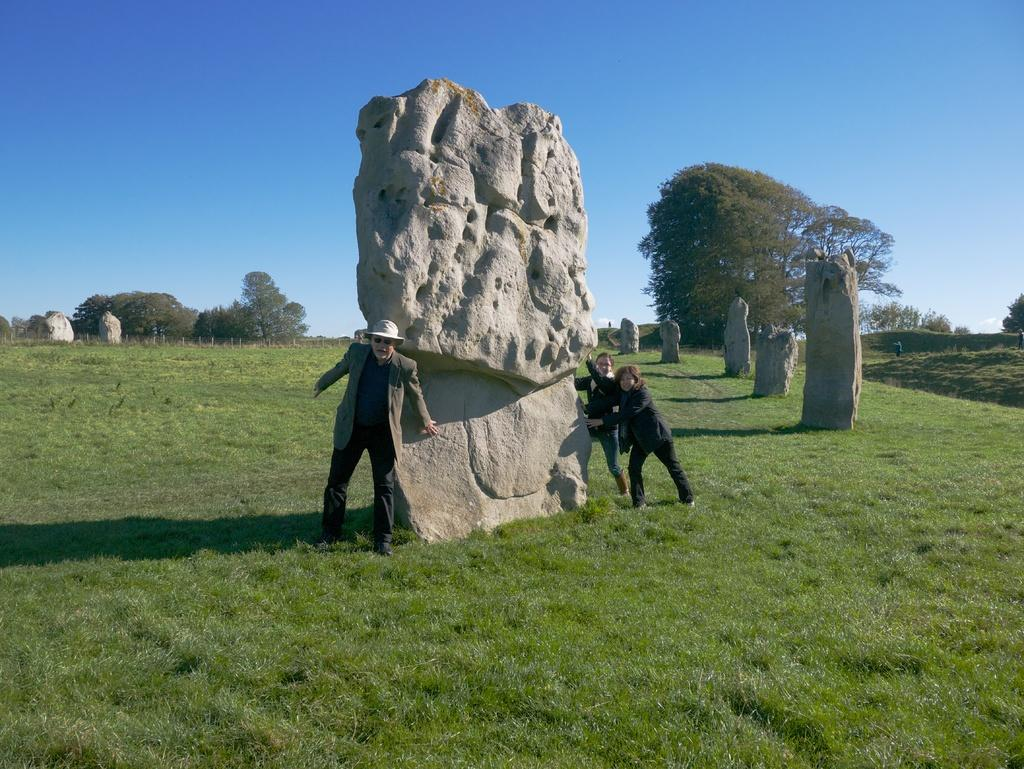What type of natural elements can be seen in the image? There are rocks in the image. Who or what else is present in the image? There are people in the image. What is the surface that the people are standing on? The people are on a grass floor. What type of vegetation is visible in the image? There are trees around the area in the image. What type of dental issue is the person in the image experiencing? There is no indication of any dental issues in the image; the focus is on the rocks, people, grass floor, and trees. 